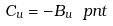Convert formula to latex. <formula><loc_0><loc_0><loc_500><loc_500>C _ { u } = - B _ { u } \ p n t</formula> 